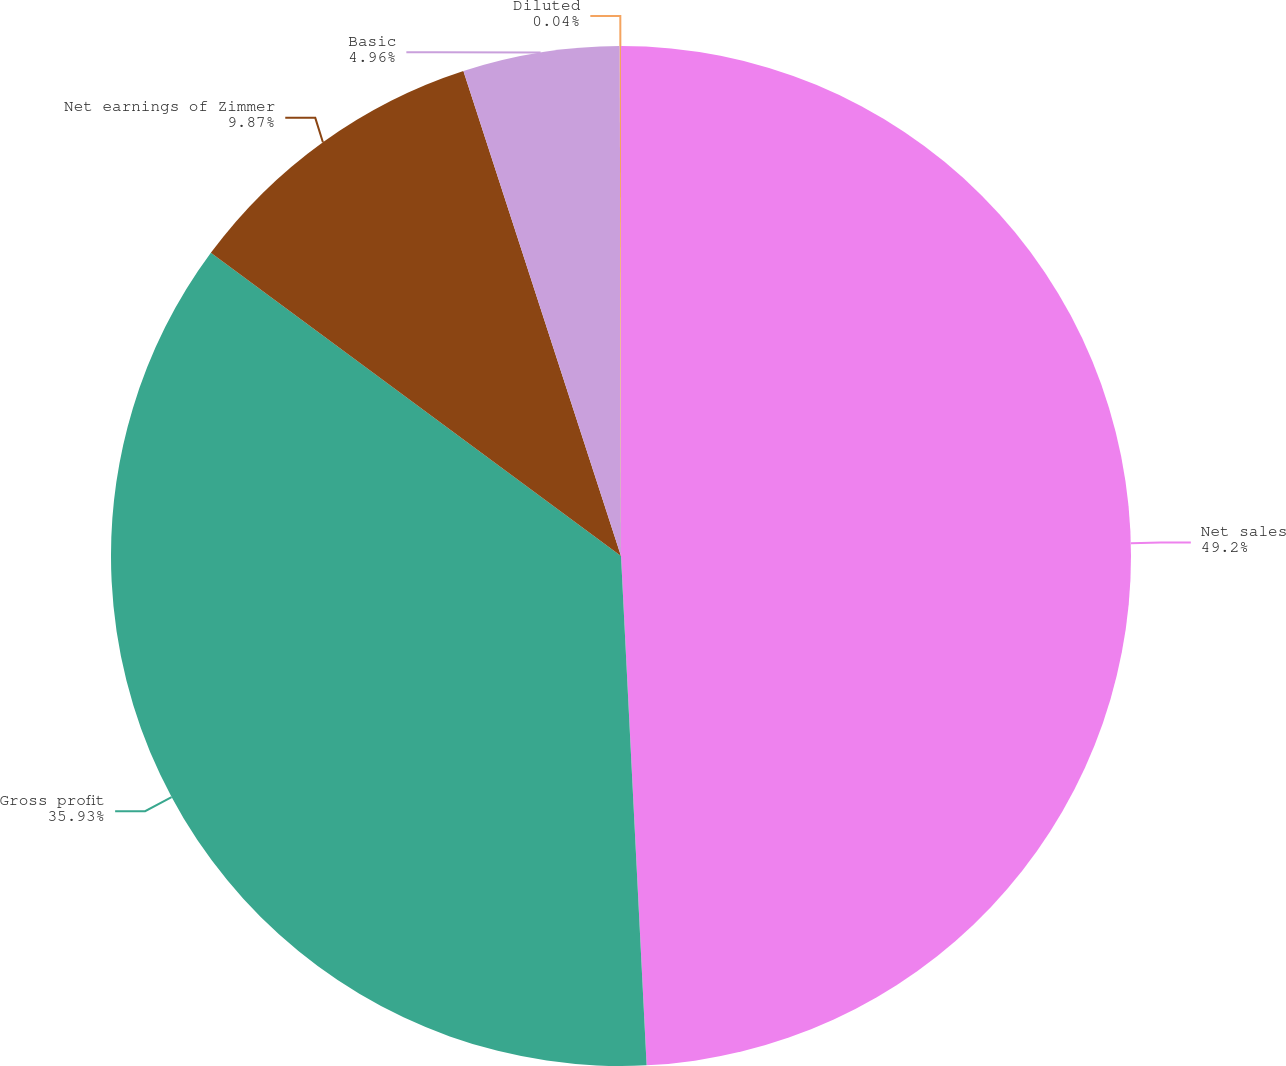Convert chart. <chart><loc_0><loc_0><loc_500><loc_500><pie_chart><fcel>Net sales<fcel>Gross profit<fcel>Net earnings of Zimmer<fcel>Basic<fcel>Diluted<nl><fcel>49.2%<fcel>35.93%<fcel>9.87%<fcel>4.96%<fcel>0.04%<nl></chart> 